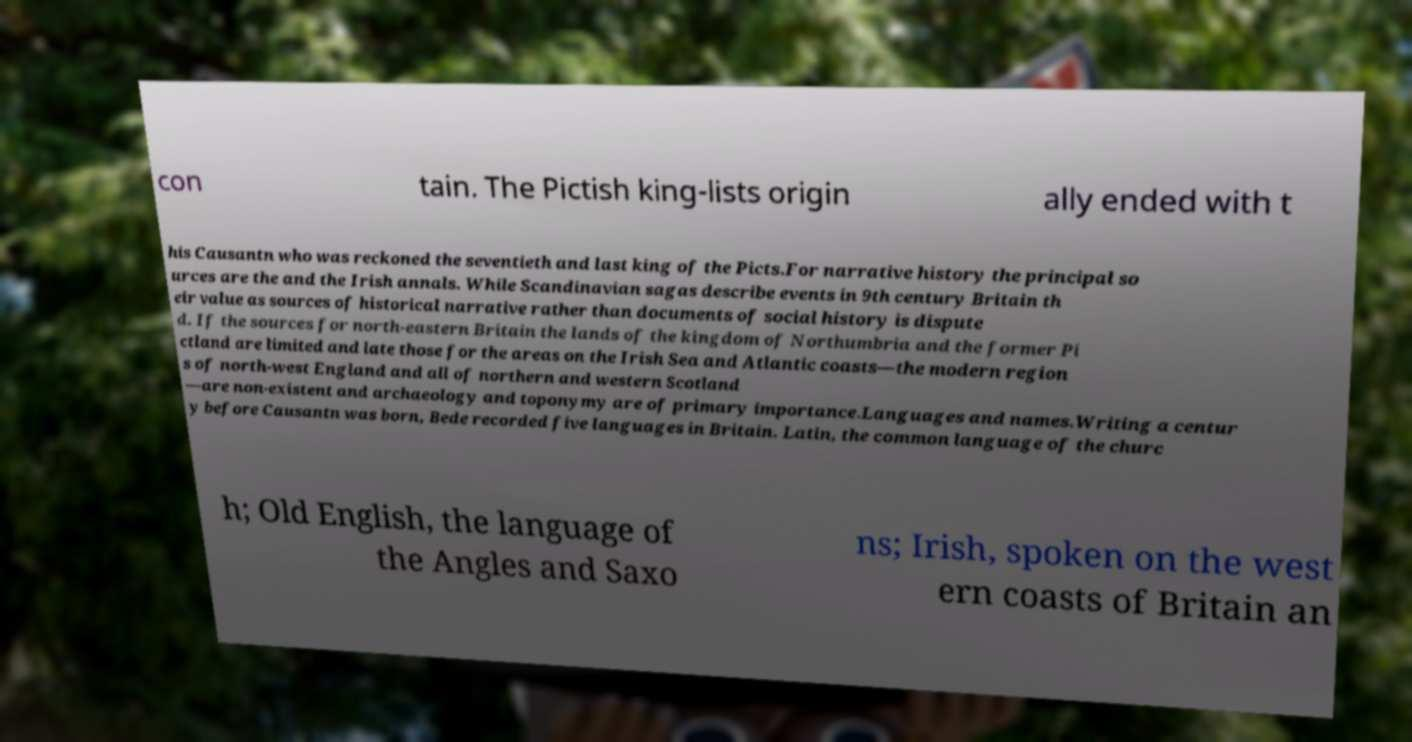Please identify and transcribe the text found in this image. con tain. The Pictish king-lists origin ally ended with t his Causantn who was reckoned the seventieth and last king of the Picts.For narrative history the principal so urces are the and the Irish annals. While Scandinavian sagas describe events in 9th century Britain th eir value as sources of historical narrative rather than documents of social history is dispute d. If the sources for north-eastern Britain the lands of the kingdom of Northumbria and the former Pi ctland are limited and late those for the areas on the Irish Sea and Atlantic coasts—the modern region s of north-west England and all of northern and western Scotland —are non-existent and archaeology and toponymy are of primary importance.Languages and names.Writing a centur y before Causantn was born, Bede recorded five languages in Britain. Latin, the common language of the churc h; Old English, the language of the Angles and Saxo ns; Irish, spoken on the west ern coasts of Britain an 